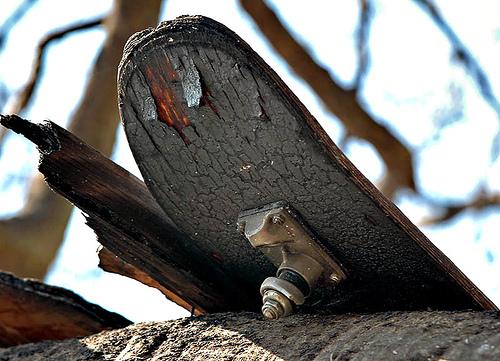What disaster happened here?
Concise answer only. Fire. Is it daytime?
Quick response, please. Yes. Does something appear broken in the picture?
Be succinct. Yes. 